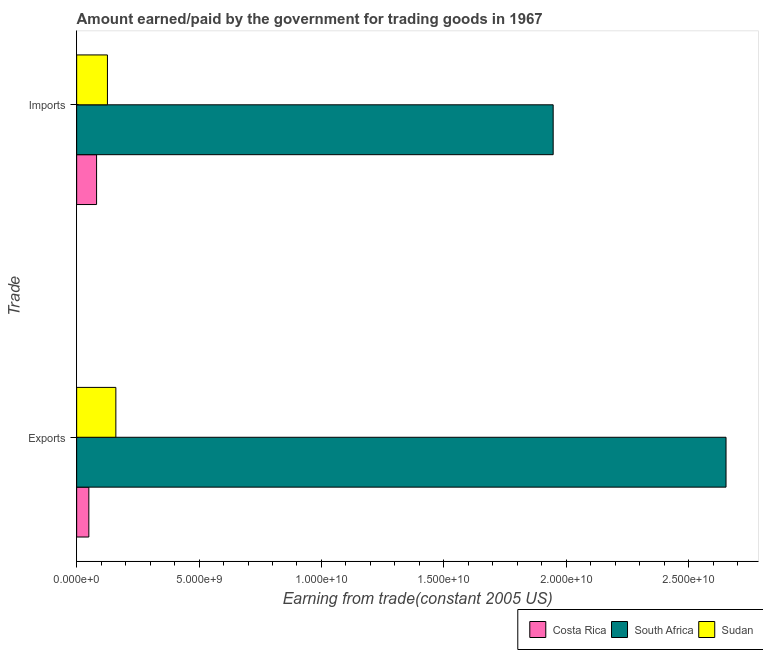Are the number of bars per tick equal to the number of legend labels?
Keep it short and to the point. Yes. Are the number of bars on each tick of the Y-axis equal?
Your answer should be very brief. Yes. How many bars are there on the 2nd tick from the bottom?
Your answer should be very brief. 3. What is the label of the 2nd group of bars from the top?
Provide a succinct answer. Exports. What is the amount paid for imports in Costa Rica?
Provide a short and direct response. 8.13e+08. Across all countries, what is the maximum amount earned from exports?
Provide a succinct answer. 2.65e+1. Across all countries, what is the minimum amount paid for imports?
Provide a short and direct response. 8.13e+08. In which country was the amount earned from exports maximum?
Provide a short and direct response. South Africa. In which country was the amount paid for imports minimum?
Provide a short and direct response. Costa Rica. What is the total amount paid for imports in the graph?
Give a very brief answer. 2.15e+1. What is the difference between the amount earned from exports in Sudan and that in South Africa?
Your answer should be very brief. -2.49e+1. What is the difference between the amount paid for imports in Sudan and the amount earned from exports in Costa Rica?
Provide a succinct answer. 7.59e+08. What is the average amount paid for imports per country?
Ensure brevity in your answer.  7.18e+09. What is the difference between the amount paid for imports and amount earned from exports in South Africa?
Offer a terse response. -7.06e+09. In how many countries, is the amount earned from exports greater than 15000000000 US$?
Your response must be concise. 1. What is the ratio of the amount paid for imports in South Africa to that in Sudan?
Provide a succinct answer. 15.49. In how many countries, is the amount earned from exports greater than the average amount earned from exports taken over all countries?
Your answer should be compact. 1. What does the 1st bar from the bottom in Imports represents?
Your answer should be compact. Costa Rica. Are all the bars in the graph horizontal?
Your response must be concise. Yes. How many countries are there in the graph?
Keep it short and to the point. 3. What is the difference between two consecutive major ticks on the X-axis?
Make the answer very short. 5.00e+09. Does the graph contain any zero values?
Provide a succinct answer. No. Does the graph contain grids?
Your answer should be compact. No. How many legend labels are there?
Offer a very short reply. 3. What is the title of the graph?
Provide a short and direct response. Amount earned/paid by the government for trading goods in 1967. Does "Mali" appear as one of the legend labels in the graph?
Provide a short and direct response. No. What is the label or title of the X-axis?
Offer a terse response. Earning from trade(constant 2005 US). What is the label or title of the Y-axis?
Your response must be concise. Trade. What is the Earning from trade(constant 2005 US) of Costa Rica in Exports?
Provide a short and direct response. 4.98e+08. What is the Earning from trade(constant 2005 US) in South Africa in Exports?
Your answer should be compact. 2.65e+1. What is the Earning from trade(constant 2005 US) of Sudan in Exports?
Offer a very short reply. 1.60e+09. What is the Earning from trade(constant 2005 US) in Costa Rica in Imports?
Your answer should be compact. 8.13e+08. What is the Earning from trade(constant 2005 US) in South Africa in Imports?
Provide a succinct answer. 1.95e+1. What is the Earning from trade(constant 2005 US) in Sudan in Imports?
Offer a terse response. 1.26e+09. Across all Trade, what is the maximum Earning from trade(constant 2005 US) in Costa Rica?
Offer a terse response. 8.13e+08. Across all Trade, what is the maximum Earning from trade(constant 2005 US) in South Africa?
Offer a terse response. 2.65e+1. Across all Trade, what is the maximum Earning from trade(constant 2005 US) in Sudan?
Provide a short and direct response. 1.60e+09. Across all Trade, what is the minimum Earning from trade(constant 2005 US) in Costa Rica?
Offer a terse response. 4.98e+08. Across all Trade, what is the minimum Earning from trade(constant 2005 US) in South Africa?
Your answer should be very brief. 1.95e+1. Across all Trade, what is the minimum Earning from trade(constant 2005 US) in Sudan?
Your answer should be compact. 1.26e+09. What is the total Earning from trade(constant 2005 US) in Costa Rica in the graph?
Your answer should be very brief. 1.31e+09. What is the total Earning from trade(constant 2005 US) in South Africa in the graph?
Give a very brief answer. 4.60e+1. What is the total Earning from trade(constant 2005 US) in Sudan in the graph?
Your answer should be very brief. 2.86e+09. What is the difference between the Earning from trade(constant 2005 US) in Costa Rica in Exports and that in Imports?
Give a very brief answer. -3.16e+08. What is the difference between the Earning from trade(constant 2005 US) of South Africa in Exports and that in Imports?
Make the answer very short. 7.06e+09. What is the difference between the Earning from trade(constant 2005 US) of Sudan in Exports and that in Imports?
Provide a short and direct response. 3.44e+08. What is the difference between the Earning from trade(constant 2005 US) of Costa Rica in Exports and the Earning from trade(constant 2005 US) of South Africa in Imports?
Provide a succinct answer. -1.90e+1. What is the difference between the Earning from trade(constant 2005 US) of Costa Rica in Exports and the Earning from trade(constant 2005 US) of Sudan in Imports?
Make the answer very short. -7.59e+08. What is the difference between the Earning from trade(constant 2005 US) of South Africa in Exports and the Earning from trade(constant 2005 US) of Sudan in Imports?
Offer a terse response. 2.53e+1. What is the average Earning from trade(constant 2005 US) of Costa Rica per Trade?
Your response must be concise. 6.56e+08. What is the average Earning from trade(constant 2005 US) of South Africa per Trade?
Offer a very short reply. 2.30e+1. What is the average Earning from trade(constant 2005 US) in Sudan per Trade?
Ensure brevity in your answer.  1.43e+09. What is the difference between the Earning from trade(constant 2005 US) of Costa Rica and Earning from trade(constant 2005 US) of South Africa in Exports?
Your answer should be very brief. -2.60e+1. What is the difference between the Earning from trade(constant 2005 US) of Costa Rica and Earning from trade(constant 2005 US) of Sudan in Exports?
Your answer should be very brief. -1.10e+09. What is the difference between the Earning from trade(constant 2005 US) in South Africa and Earning from trade(constant 2005 US) in Sudan in Exports?
Your answer should be compact. 2.49e+1. What is the difference between the Earning from trade(constant 2005 US) of Costa Rica and Earning from trade(constant 2005 US) of South Africa in Imports?
Your answer should be very brief. -1.87e+1. What is the difference between the Earning from trade(constant 2005 US) of Costa Rica and Earning from trade(constant 2005 US) of Sudan in Imports?
Offer a very short reply. -4.44e+08. What is the difference between the Earning from trade(constant 2005 US) of South Africa and Earning from trade(constant 2005 US) of Sudan in Imports?
Your response must be concise. 1.82e+1. What is the ratio of the Earning from trade(constant 2005 US) of Costa Rica in Exports to that in Imports?
Your answer should be compact. 0.61. What is the ratio of the Earning from trade(constant 2005 US) in South Africa in Exports to that in Imports?
Offer a very short reply. 1.36. What is the ratio of the Earning from trade(constant 2005 US) of Sudan in Exports to that in Imports?
Your answer should be very brief. 1.27. What is the difference between the highest and the second highest Earning from trade(constant 2005 US) of Costa Rica?
Offer a terse response. 3.16e+08. What is the difference between the highest and the second highest Earning from trade(constant 2005 US) in South Africa?
Provide a short and direct response. 7.06e+09. What is the difference between the highest and the second highest Earning from trade(constant 2005 US) in Sudan?
Provide a short and direct response. 3.44e+08. What is the difference between the highest and the lowest Earning from trade(constant 2005 US) of Costa Rica?
Keep it short and to the point. 3.16e+08. What is the difference between the highest and the lowest Earning from trade(constant 2005 US) in South Africa?
Give a very brief answer. 7.06e+09. What is the difference between the highest and the lowest Earning from trade(constant 2005 US) of Sudan?
Your answer should be very brief. 3.44e+08. 